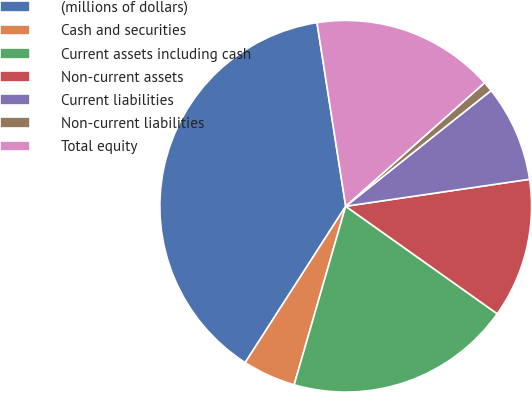Convert chart to OTSL. <chart><loc_0><loc_0><loc_500><loc_500><pie_chart><fcel>(millions of dollars)<fcel>Cash and securities<fcel>Current assets including cash<fcel>Non-current assets<fcel>Current liabilities<fcel>Non-current liabilities<fcel>Total equity<nl><fcel>38.44%<fcel>4.62%<fcel>19.65%<fcel>12.14%<fcel>8.38%<fcel>0.87%<fcel>15.9%<nl></chart> 